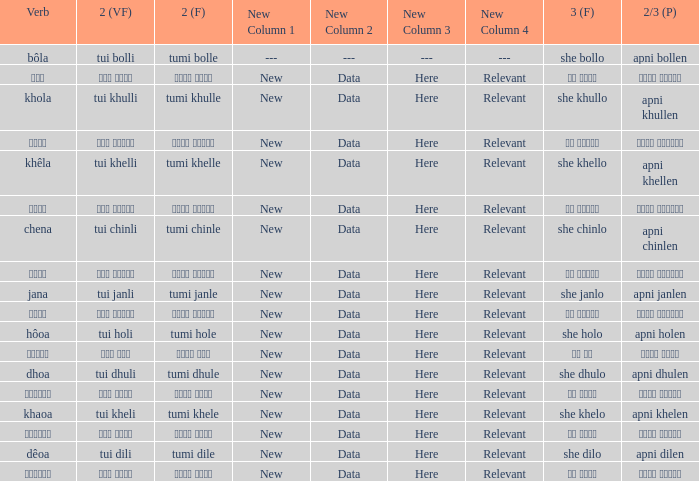What is the 2nd verb for chena? Tumi chinle. 